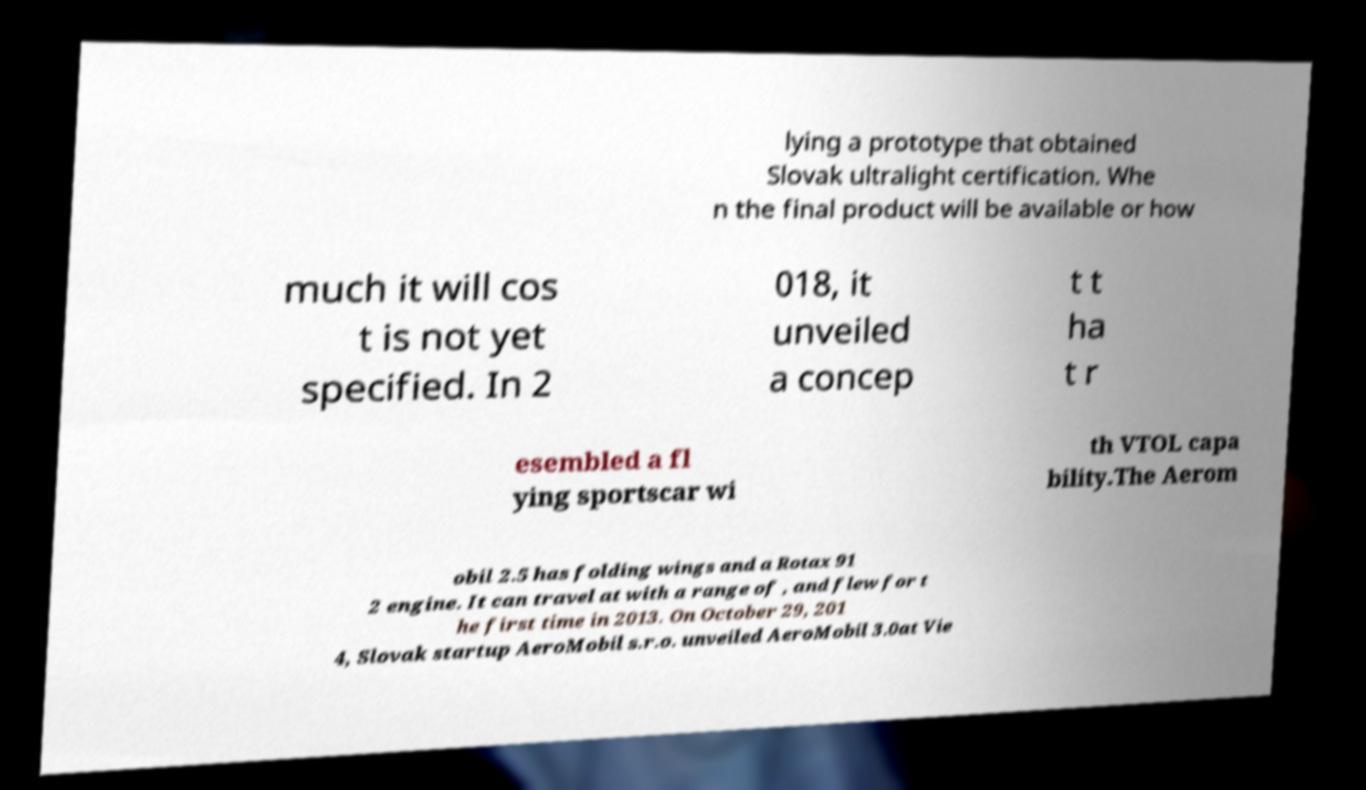I need the written content from this picture converted into text. Can you do that? lying a prototype that obtained Slovak ultralight certification. Whe n the final product will be available or how much it will cos t is not yet specified. In 2 018, it unveiled a concep t t ha t r esembled a fl ying sportscar wi th VTOL capa bility.The Aerom obil 2.5 has folding wings and a Rotax 91 2 engine. It can travel at with a range of , and flew for t he first time in 2013. On October 29, 201 4, Slovak startup AeroMobil s.r.o. unveiled AeroMobil 3.0at Vie 